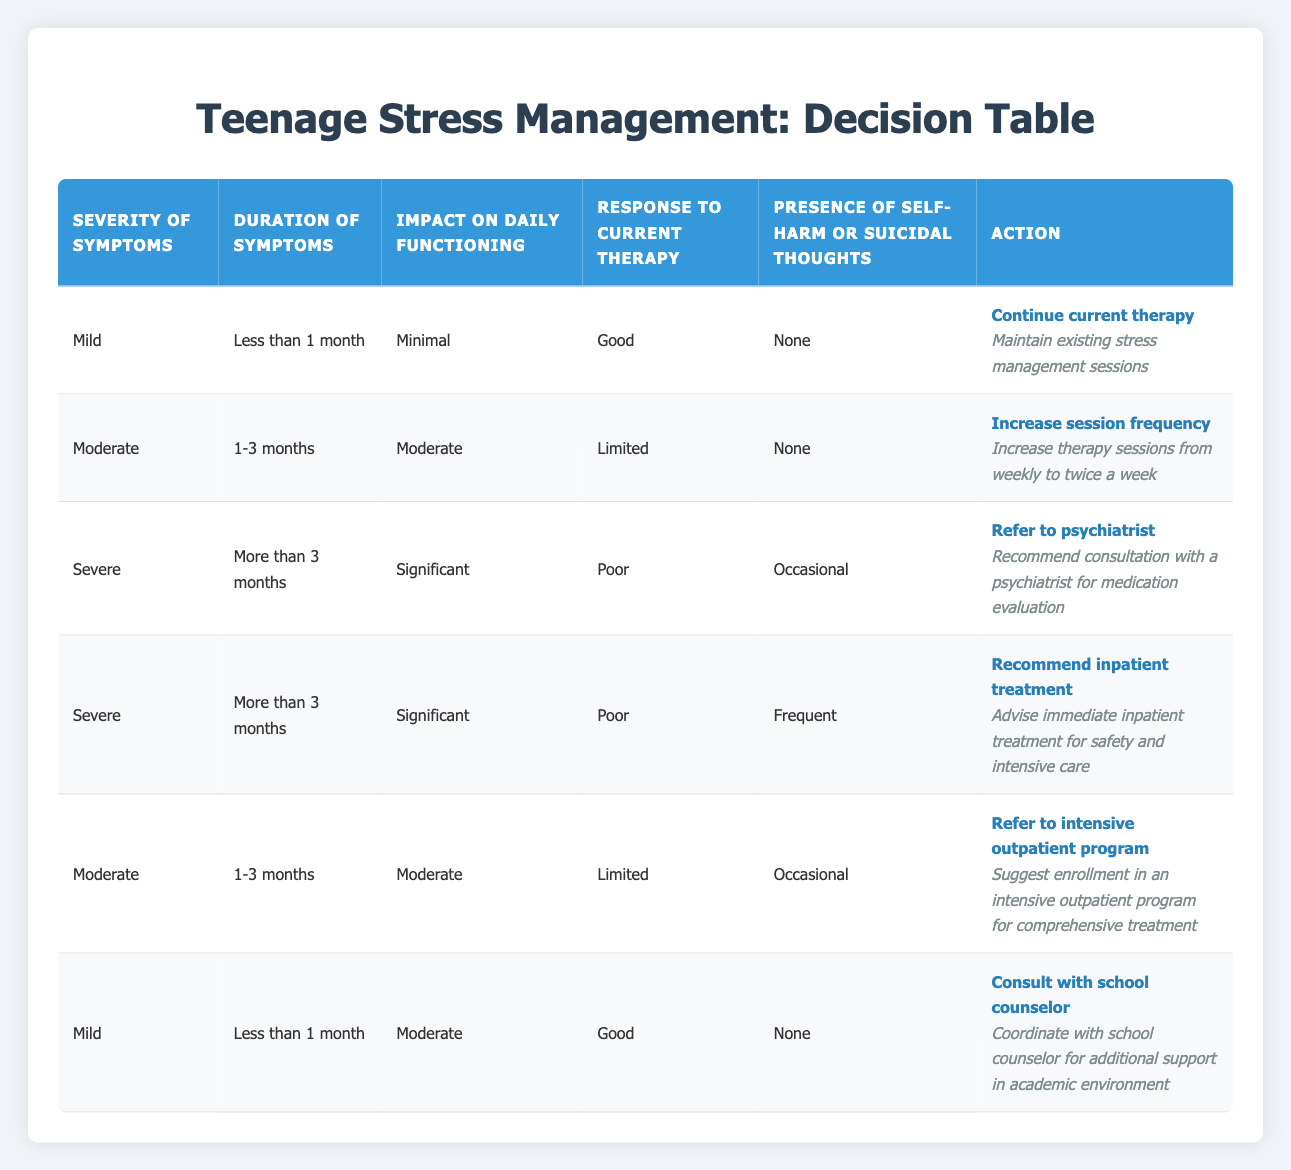What action is recommended for a teenager with severe symptoms lasting more than 3 months, who has significant impact on daily functioning, a poor response to current therapy, and frequent self-harm thoughts? According to the table, the appropriate action in this specific scenario is to "Recommend inpatient treatment." This is defined under the corresponding conditions in the table that match the criteria described.
Answer: Recommend inpatient treatment Which action is suggested for mild symptoms that have lasted less than 1 month with minimal impact on daily functioning, a good response to therapy, and no self-harm thoughts? The table indicates that for this situation, the action to take is "Continue current therapy," as it perfectly aligns with the conditions given.
Answer: Continue current therapy Is it true that increasing session frequency is recommended for teenagers with moderate symptoms lasting 1-3 months and a limited response to current therapy? Yes, it is true. The table lists this specific combination of conditions as a basis for the action to increase session frequency.
Answer: Yes What action should be taken for moderate symptoms with a duration of 1-3 months, moderate impact on daily functioning, limited response to therapy, and occasional self-harm thoughts? In the table, this scenario aligns with the condition set for referring to an intensive outpatient program, as per the corresponding rule.
Answer: Refer to intensive outpatient program How many total actions are associated with severe symptoms? By examining the table, there are two actions related to severe symptoms. These actions include referring to a psychiatrist and recommending inpatient treatment.
Answer: 2 What is the least severe condition for which consulting with a school counselor is recommended? The conditions for consulting with a school counselor is for mild symptoms, lasting less than 1 month, with a moderate impact on daily functioning, a good response to therapy, and no self-harm thoughts, which makes it the least severe.
Answer: Mild symptoms If a teenager shows moderate symptoms for 1-3 months with minimal daily functioning impact, is "Continue current therapy" an appropriate action? No, this action does not align with the specified conditions for moderate symptoms with minimal impact. According to the table, "Continue current therapy" is only applicable to "Mild" symptoms.
Answer: No What are the conditions listed that lead to a referral to a psychiatrist? The conditions for referral to a psychiatrist are severe symptoms lasting more than 3 months, with significant impact on daily functioning, a poor response to therapy, and occasional self-harm thoughts.
Answer: Severe symptoms, more than 3 months, significant impact, poor response, occasional self-harm If a teenager has mild symptoms lasting less than 1 month, moderate daily impact, a good response to therapy, and occasional self-harm, what is the recommended action? In this case, the recommended action does not match any rule specifically in the table. The closest is consulting with a school counselor, but the self-harm presence renders it unnecessary. Thus, no action is defined under the present rules for these specific conditions.
Answer: No defined action 